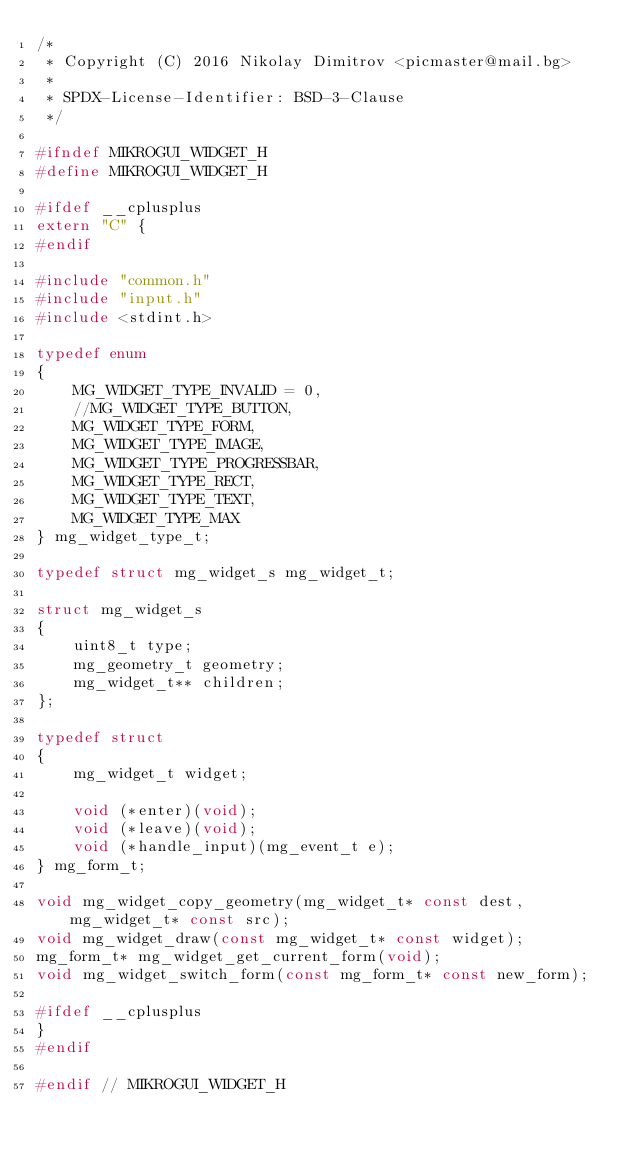<code> <loc_0><loc_0><loc_500><loc_500><_C_>/*
 * Copyright (C) 2016 Nikolay Dimitrov <picmaster@mail.bg>
 *
 * SPDX-License-Identifier: BSD-3-Clause
 */

#ifndef MIKROGUI_WIDGET_H
#define MIKROGUI_WIDGET_H

#ifdef __cplusplus
extern "C" {
#endif

#include "common.h"
#include "input.h"
#include <stdint.h>

typedef enum
{
    MG_WIDGET_TYPE_INVALID = 0,
    //MG_WIDGET_TYPE_BUTTON,
    MG_WIDGET_TYPE_FORM,
    MG_WIDGET_TYPE_IMAGE,
    MG_WIDGET_TYPE_PROGRESSBAR,
    MG_WIDGET_TYPE_RECT,
    MG_WIDGET_TYPE_TEXT,
    MG_WIDGET_TYPE_MAX
} mg_widget_type_t;

typedef struct mg_widget_s mg_widget_t;

struct mg_widget_s
{
    uint8_t type;
    mg_geometry_t geometry;
    mg_widget_t** children;
};

typedef struct
{
    mg_widget_t widget;

    void (*enter)(void);
    void (*leave)(void);
    void (*handle_input)(mg_event_t e);
} mg_form_t;

void mg_widget_copy_geometry(mg_widget_t* const dest, mg_widget_t* const src);
void mg_widget_draw(const mg_widget_t* const widget);
mg_form_t* mg_widget_get_current_form(void);
void mg_widget_switch_form(const mg_form_t* const new_form);

#ifdef __cplusplus
}
#endif

#endif // MIKROGUI_WIDGET_H

</code> 